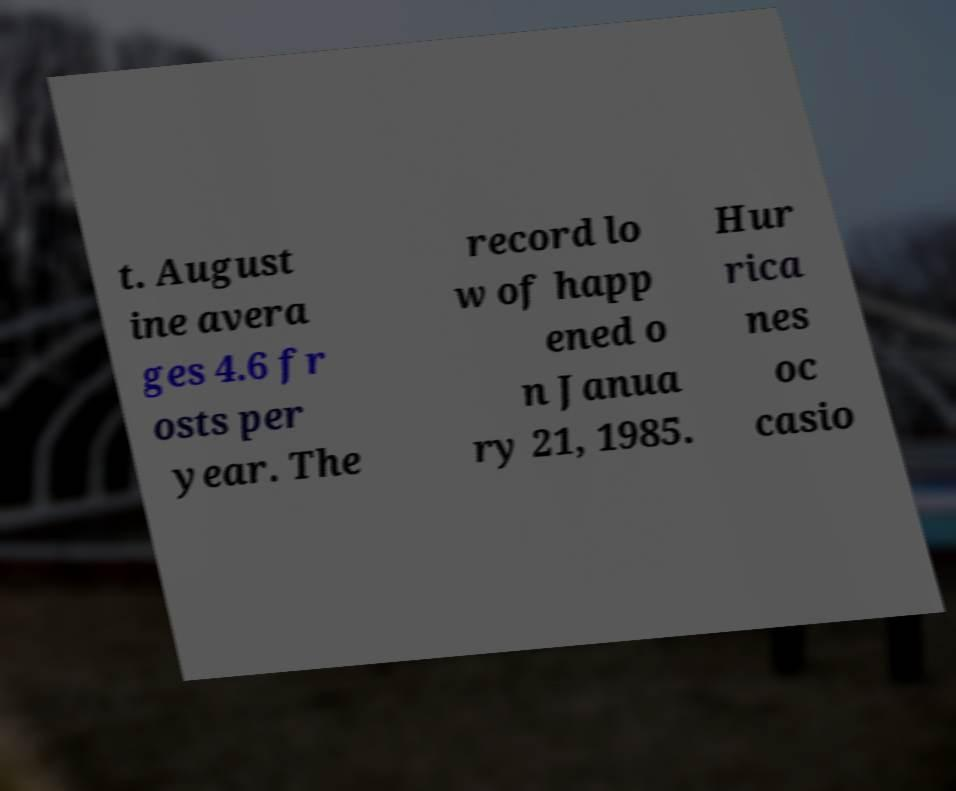Could you assist in decoding the text presented in this image and type it out clearly? t. August ine avera ges 4.6 fr osts per year. The record lo w of happ ened o n Janua ry 21, 1985. Hur rica nes oc casio 